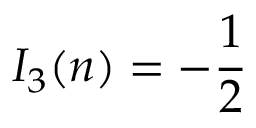Convert formula to latex. <formula><loc_0><loc_0><loc_500><loc_500>I _ { 3 } ( n ) = - { \frac { 1 } { 2 } }</formula> 